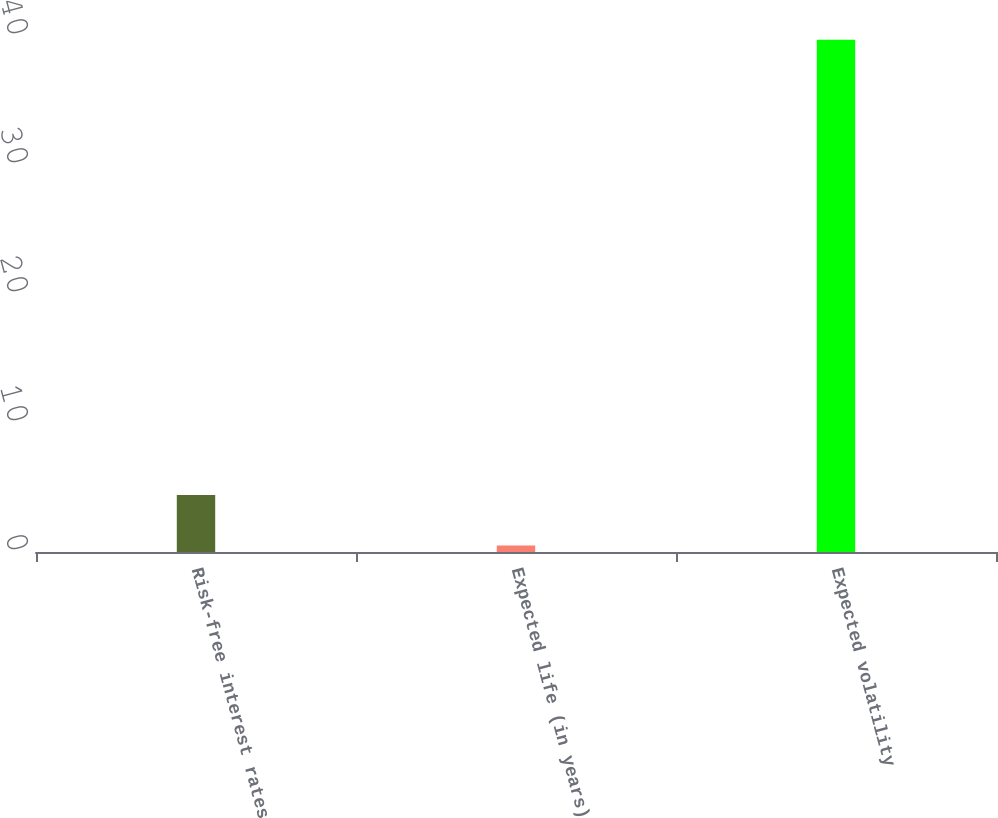<chart> <loc_0><loc_0><loc_500><loc_500><bar_chart><fcel>Risk-free interest rates<fcel>Expected life (in years)<fcel>Expected volatility<nl><fcel>4.42<fcel>0.5<fcel>39.7<nl></chart> 